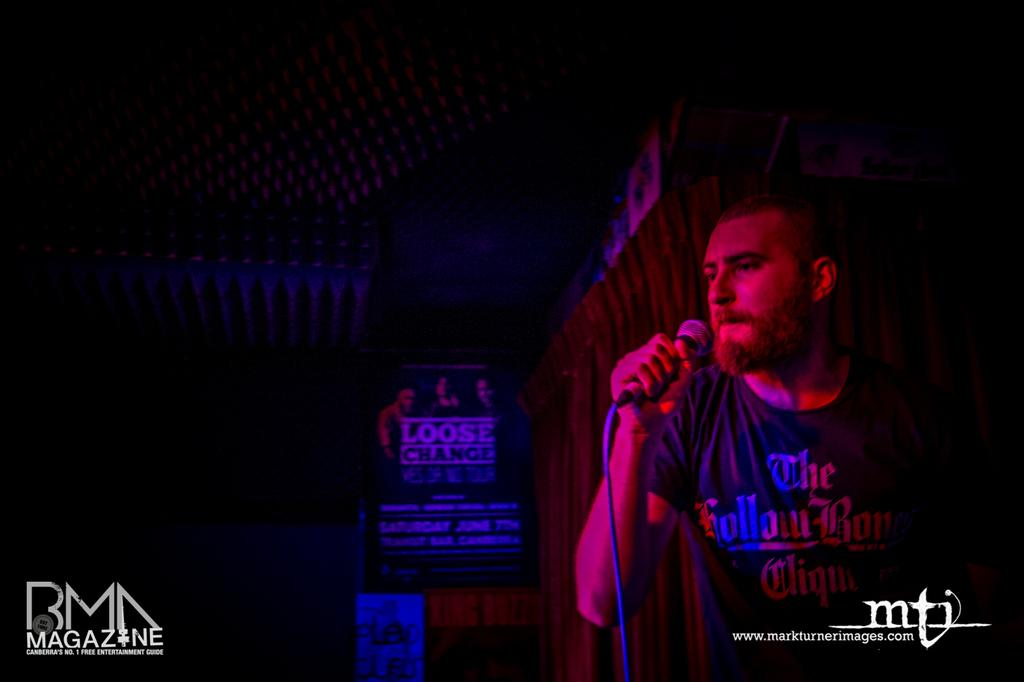What is the man in the image doing? The man is singing a song in the image. What object is the man holding while singing? The man is holding a microphone in the image. What is the man wearing in the image? The man is wearing a black T-shirt in the image. What can be seen in the background of the image? There is a curtain visible in the image. What is written on the board in the image? There is a board with a name on it in the image. What is the purpose of the chairs in the image? There are no chairs present in the image, so it is not possible to determine their purpose. 